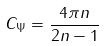Convert formula to latex. <formula><loc_0><loc_0><loc_500><loc_500>C _ { \Psi } = \frac { 4 \pi n } { 2 n - 1 }</formula> 